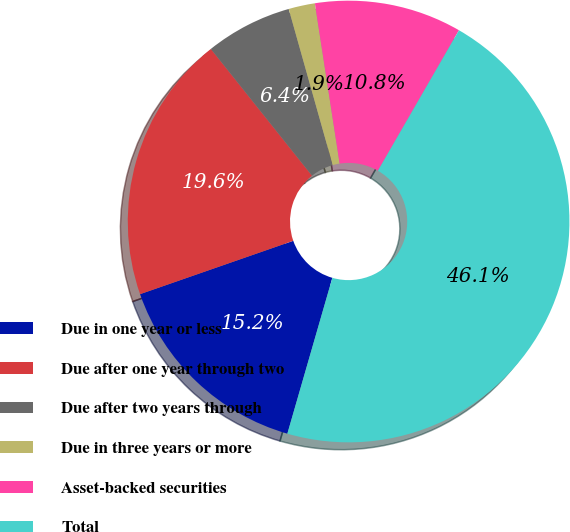<chart> <loc_0><loc_0><loc_500><loc_500><pie_chart><fcel>Due in one year or less<fcel>Due after one year through two<fcel>Due after two years through<fcel>Due in three years or more<fcel>Asset-backed securities<fcel>Total<nl><fcel>15.19%<fcel>19.61%<fcel>6.35%<fcel>1.93%<fcel>10.77%<fcel>46.14%<nl></chart> 